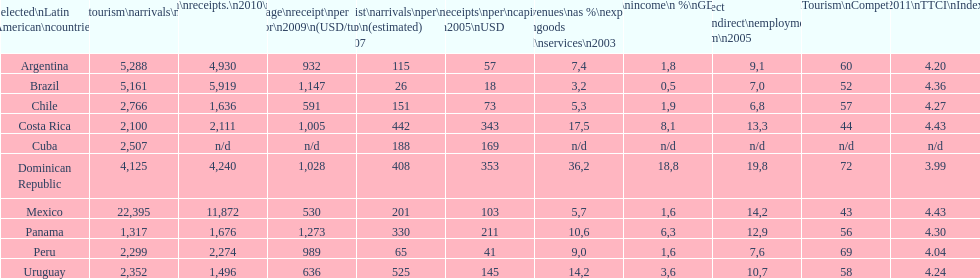In which country do most categories have the best rankings? Dominican Republic. 